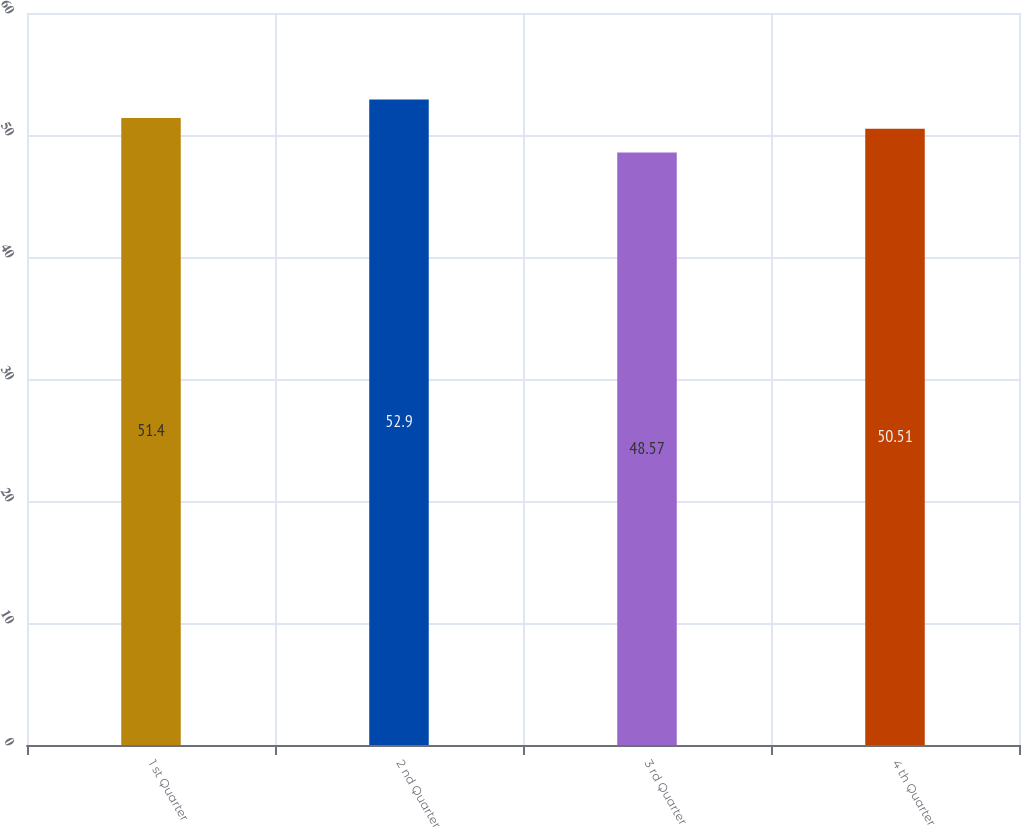<chart> <loc_0><loc_0><loc_500><loc_500><bar_chart><fcel>1 st Quarter<fcel>2 nd Quarter<fcel>3 rd Quarter<fcel>4 th Quarter<nl><fcel>51.4<fcel>52.9<fcel>48.57<fcel>50.51<nl></chart> 